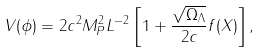<formula> <loc_0><loc_0><loc_500><loc_500>V ( \phi ) = 2 c ^ { 2 } M _ { P } ^ { 2 } L ^ { - 2 } \left [ 1 + \frac { \sqrt { \Omega _ { \Lambda } } } { 2 c } f ( X ) \right ] ,</formula> 